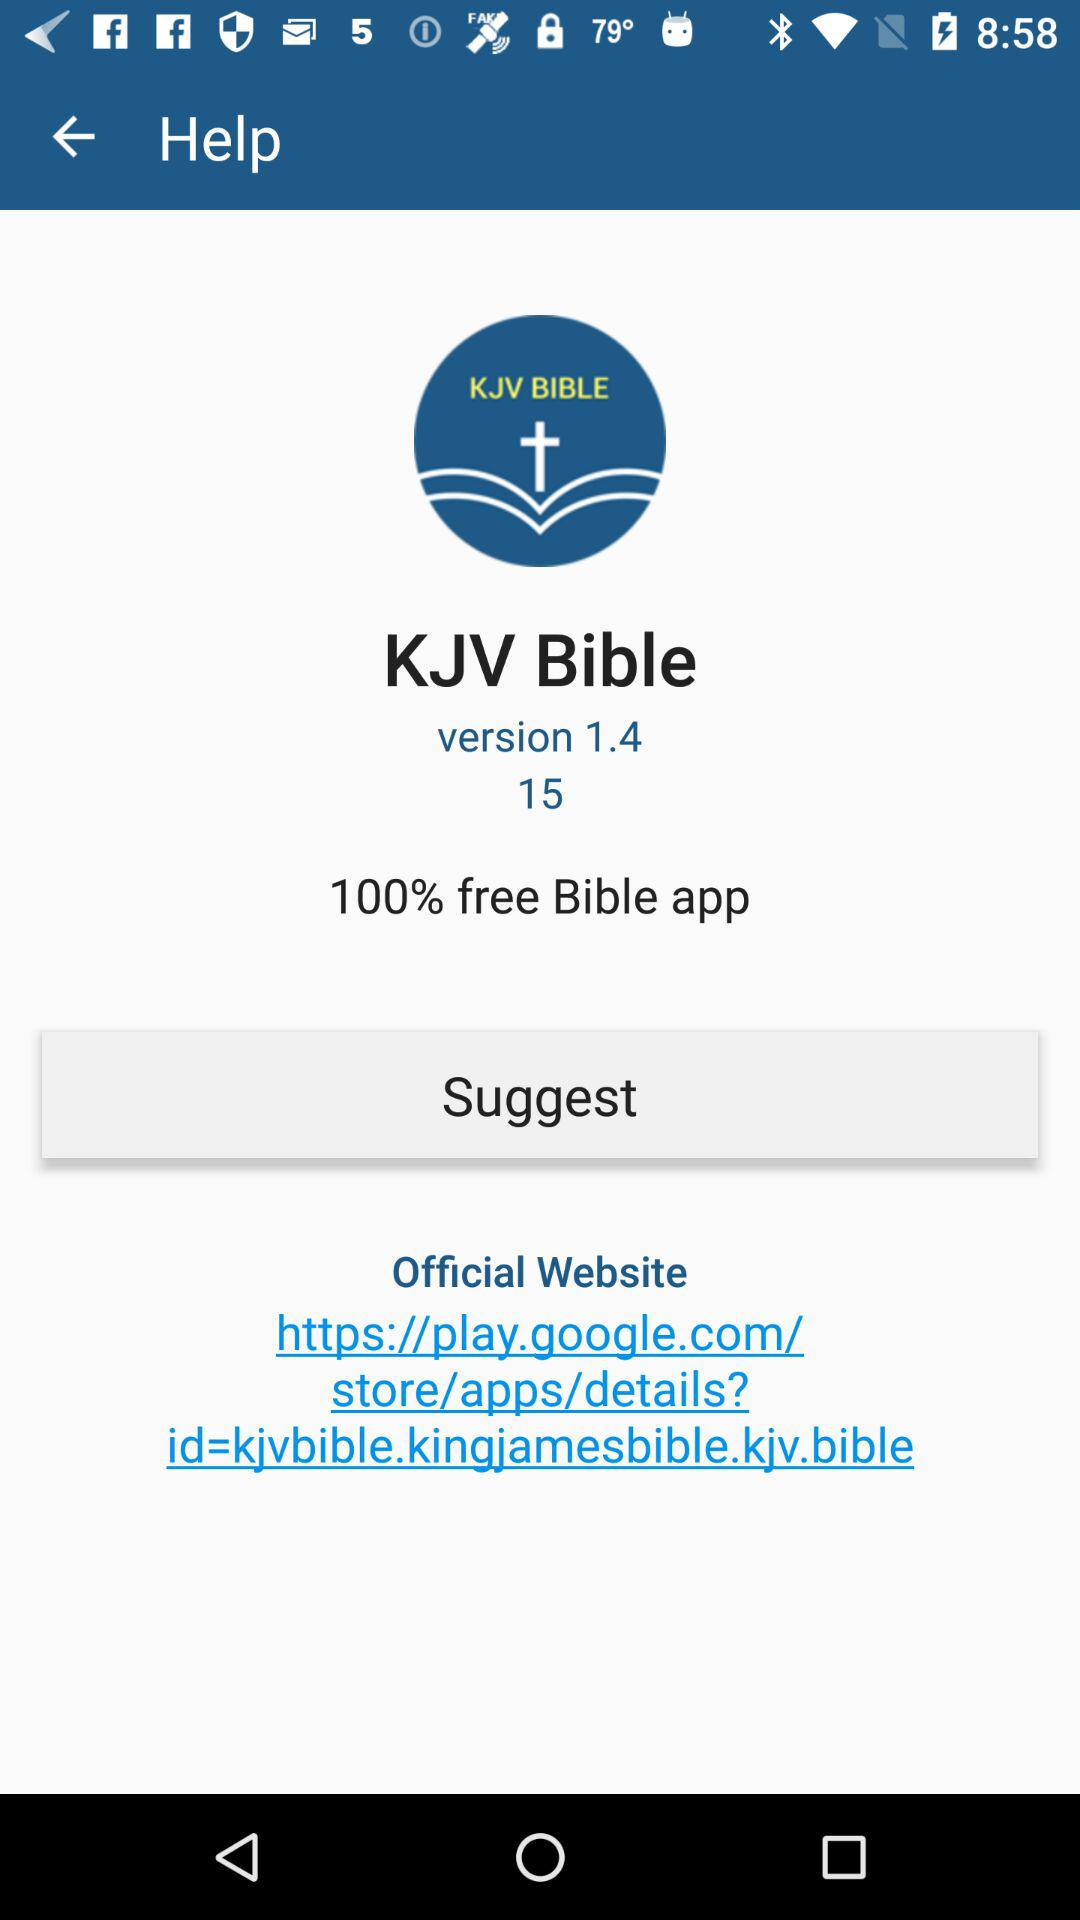What is the application name? The application name is "KJV Bible". 